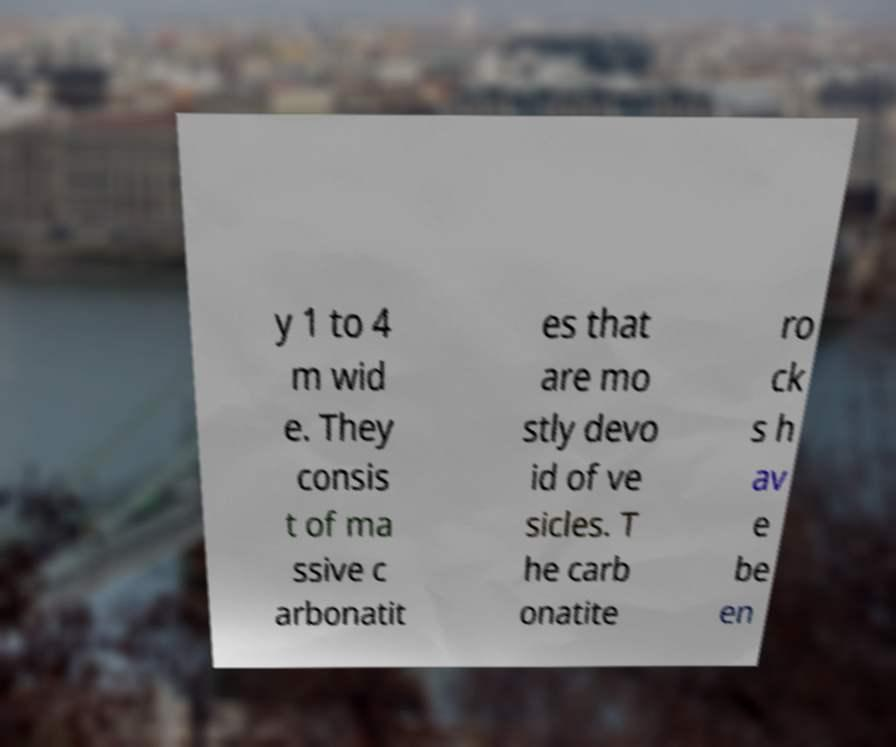Could you extract and type out the text from this image? y 1 to 4 m wid e. They consis t of ma ssive c arbonatit es that are mo stly devo id of ve sicles. T he carb onatite ro ck s h av e be en 